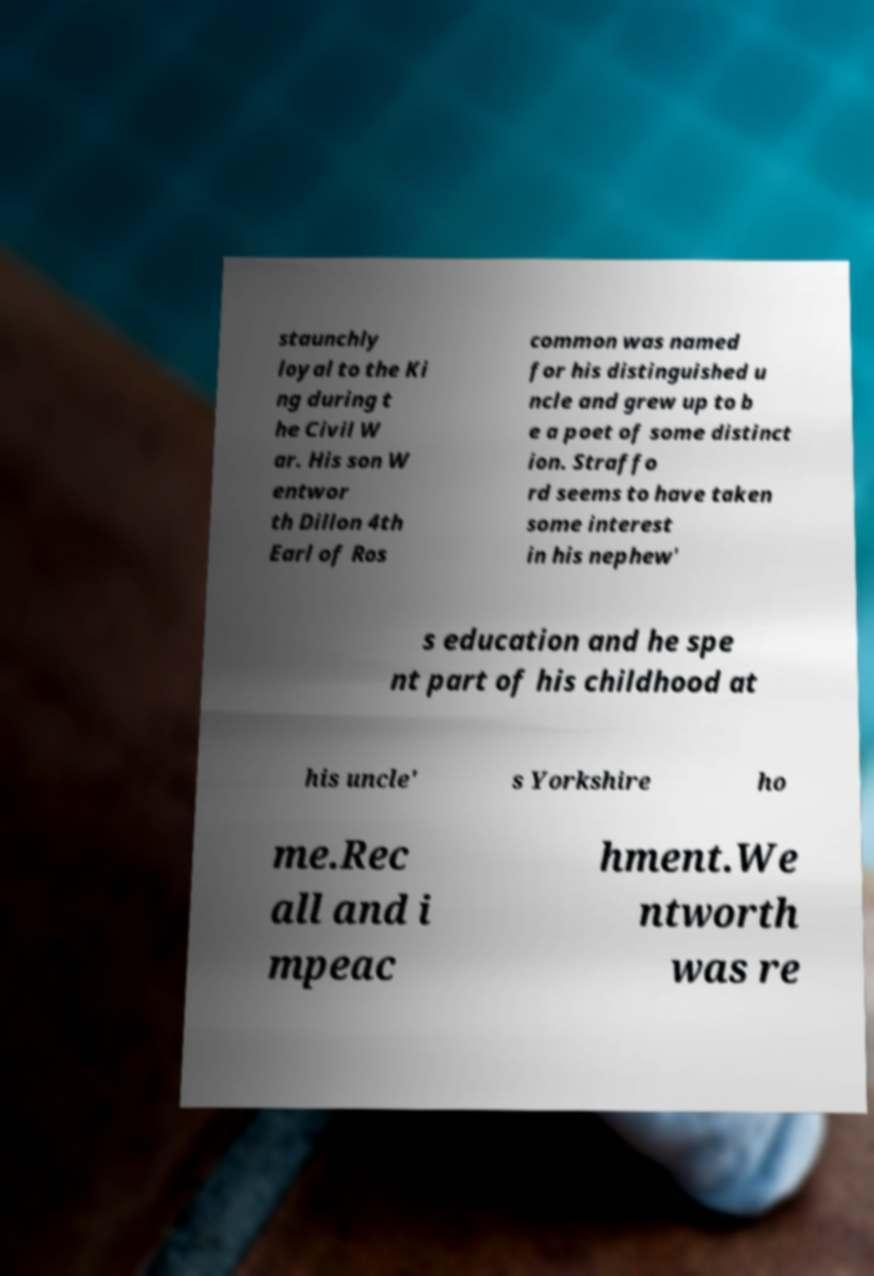What messages or text are displayed in this image? I need them in a readable, typed format. staunchly loyal to the Ki ng during t he Civil W ar. His son W entwor th Dillon 4th Earl of Ros common was named for his distinguished u ncle and grew up to b e a poet of some distinct ion. Straffo rd seems to have taken some interest in his nephew' s education and he spe nt part of his childhood at his uncle' s Yorkshire ho me.Rec all and i mpeac hment.We ntworth was re 